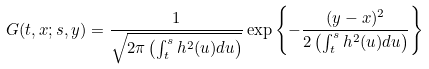Convert formula to latex. <formula><loc_0><loc_0><loc_500><loc_500>G ( t , x ; s , y ) = \frac { 1 } { \sqrt { 2 \pi \left ( \int _ { t } ^ { s } h ^ { 2 } ( u ) d u \right ) } } \exp \left \{ - \frac { ( y - x ) ^ { 2 } } { 2 \left ( \int ^ { s } _ { t } h ^ { 2 } ( u ) d u \right ) } \right \}</formula> 